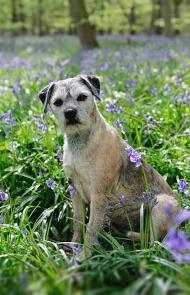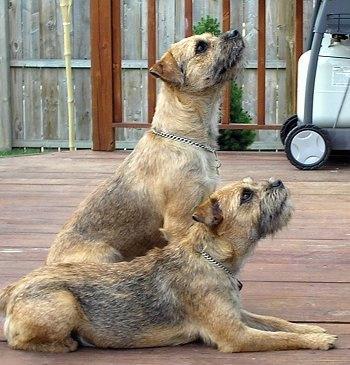The first image is the image on the left, the second image is the image on the right. Analyze the images presented: Is the assertion "The combined images include two dogs with bodies turned rightward in profile, and at least one dog with its head raised and gazing up to the right." valid? Answer yes or no. Yes. The first image is the image on the left, the second image is the image on the right. Evaluate the accuracy of this statement regarding the images: "A dog is standing on grass.". Is it true? Answer yes or no. No. 